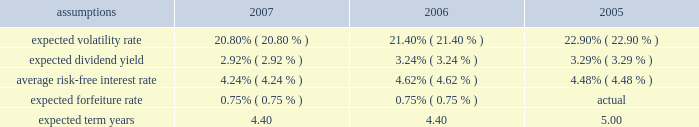Notes to the audited consolidated financial statements for 2007 , 2006 , and 2005 , total share-based compensation expense ( before tax ) of approximately $ 26 million , $ 29 million , and $ 22 million , respectively , was recognized in selling , general and administrative expense in the consolidated statement of earnings for all share-based awards of which approximately $ 13 million , $ 17 million , and $ 5 million , respectively , related to stock options .
Sfas no .
123 ( r ) requires that compensation expense is recognized over the substantive vesting period , which may be a shorter time period than the stated vesting period for retirement-eligible employees .
For 2007 and 2006 , approximately $ 3 million and $ 8 million , respectively , of stock option compensation expense were recognized due to retirement eligibility preceding the requisite vesting period .
Stock option awards option awards are granted on an annual basis to non-employee directors and to employees who meet certain eligibility requirements .
Option awards have an exercise price equal to the closing price of the company's stock on the date of grant .
The term life of options is ten years with vesting periods that vary up to three years .
Vesting usually occurs ratably over the vesting period or at the end of the vesting period .
The company utilizes the black scholes merton ( "bsm" ) option valuation model which relies on certain assumptions to estimate an option's fair value .
The weighted average assumptions used in the determination of fair value for stock options awarded in 2007 , 2006 , and 2005 are provided in the table below: .
The volatility rate of grants is derived from historical company common stock price volatility over the same time period as the expected term of each stock option award .
The volatility rate is derived by mathematical formula utilizing the weekly high closing stock price data over the expected term .
The expected dividend yield is calculated using the expected company annual dividend amount over the expected term divided by the fair market value of the company's common stock .
The average risk-free interest rate is derived from united states department of treasury published interest rates of daily yield curves for the same time period as the expected term .
Sfas no .
123 ( r ) specifies only share-based awards expected to vest be included in share-based compensation expense .
Estimated forfeiture rates are determined using historical forfeiture experience for each type of award and are excluded from the quantity of awards included in share-based compensation expense .
The weighted average expected term reflects the analysis of historical share-based award transactions and includes option swap and reload grants which may have much shorter remaining expected terms than new option grants. .
In 2007 what was the percent of the shared based compensation associated with stock options? 
Computations: (13 / 26)
Answer: 0.5. 